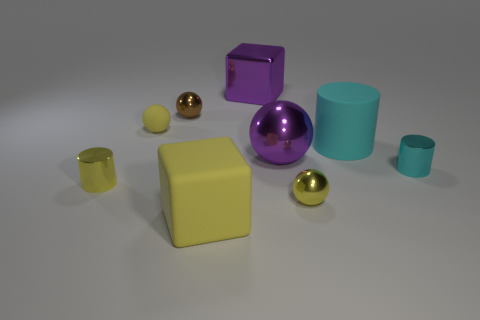Subtract all yellow metallic spheres. How many spheres are left? 3 Subtract all red balls. How many cyan cylinders are left? 2 Subtract all yellow cylinders. How many cylinders are left? 2 Add 1 big purple metal objects. How many objects exist? 10 Subtract all cubes. How many objects are left? 7 Subtract 1 blocks. How many blocks are left? 1 Add 7 purple metal spheres. How many purple metal spheres are left? 8 Add 8 big cyan matte objects. How many big cyan matte objects exist? 9 Subtract 0 purple cylinders. How many objects are left? 9 Subtract all yellow cylinders. Subtract all yellow cubes. How many cylinders are left? 2 